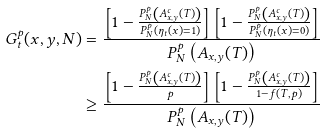<formula> <loc_0><loc_0><loc_500><loc_500>G _ { t } ^ { p } ( x , y , N ) & = \frac { \left [ 1 - \frac { P _ { N } ^ { p } \left ( A ^ { c } _ { x , y } ( T ) \right ) } { P _ { N } ^ { p } \left ( \eta _ { t } ( x ) = 1 \right ) } \right ] \left [ 1 - \frac { P _ { N } ^ { p } \left ( A ^ { c } _ { x , y } ( T ) \right ) } { P _ { N } ^ { p } \left ( \eta _ { t } ( x ) = 0 \right ) } \right ] } { P _ { N } ^ { p } \left ( A _ { x , y } ( T ) \right ) } \\ & \geq \frac { \left [ 1 - \frac { P _ { N } ^ { p } \left ( A ^ { c } _ { x , y } ( T ) \right ) } { p } \right ] \left [ 1 - \frac { P _ { N } ^ { p } \left ( A ^ { c } _ { x , y } ( T ) \right ) } { 1 - f ( T , p ) } \right ] } { P _ { N } ^ { p } \left ( A _ { x , y } ( T ) \right ) }</formula> 